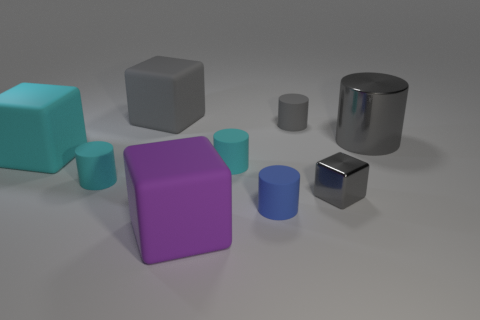Subtract all blue matte cylinders. How many cylinders are left? 4 Subtract all blue cylinders. How many cylinders are left? 4 Subtract all green cylinders. Subtract all yellow blocks. How many cylinders are left? 5 Add 1 big gray matte things. How many objects exist? 10 Subtract all cubes. How many objects are left? 5 Add 4 big cyan cubes. How many big cyan cubes exist? 5 Subtract 0 brown blocks. How many objects are left? 9 Subtract all red shiny cylinders. Subtract all tiny gray cylinders. How many objects are left? 8 Add 8 large gray objects. How many large gray objects are left? 10 